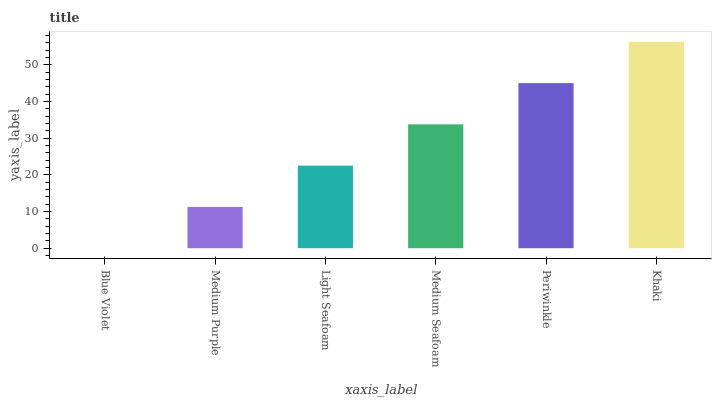Is Blue Violet the minimum?
Answer yes or no. Yes. Is Khaki the maximum?
Answer yes or no. Yes. Is Medium Purple the minimum?
Answer yes or no. No. Is Medium Purple the maximum?
Answer yes or no. No. Is Medium Purple greater than Blue Violet?
Answer yes or no. Yes. Is Blue Violet less than Medium Purple?
Answer yes or no. Yes. Is Blue Violet greater than Medium Purple?
Answer yes or no. No. Is Medium Purple less than Blue Violet?
Answer yes or no. No. Is Medium Seafoam the high median?
Answer yes or no. Yes. Is Light Seafoam the low median?
Answer yes or no. Yes. Is Light Seafoam the high median?
Answer yes or no. No. Is Blue Violet the low median?
Answer yes or no. No. 